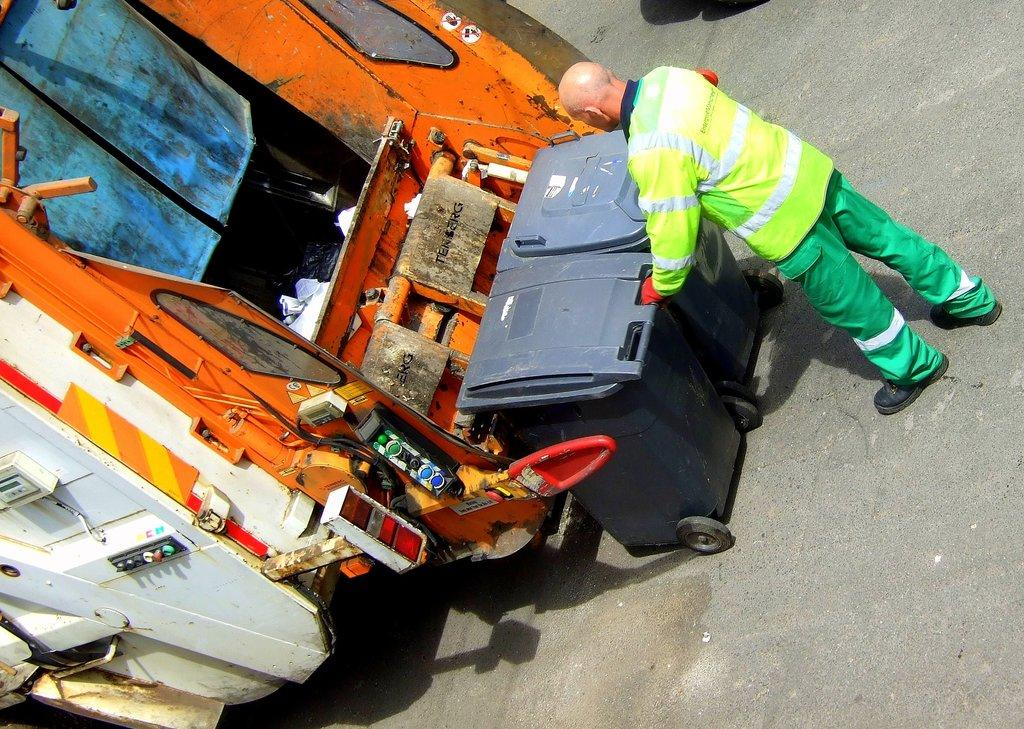What is happening in the image? There is a person in the image who is loading two trash cans. What type of vehicle is present in the image? There is a truck in the image. Can you describe the person's activity in more detail? The person is loading the trash cans onto the truck. What type of shoes is the cat wearing in the image? There is no cat present in the image, and therefore no shoes to describe. 